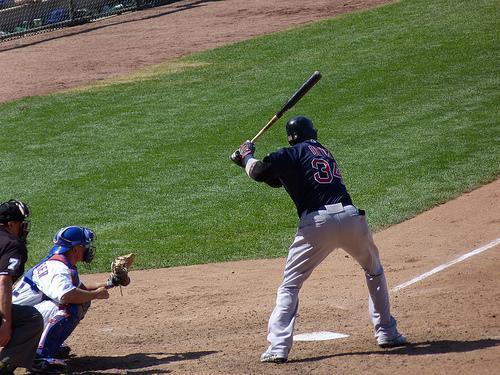How many shoes is the batter wearing?
Give a very brief answer. 2. 